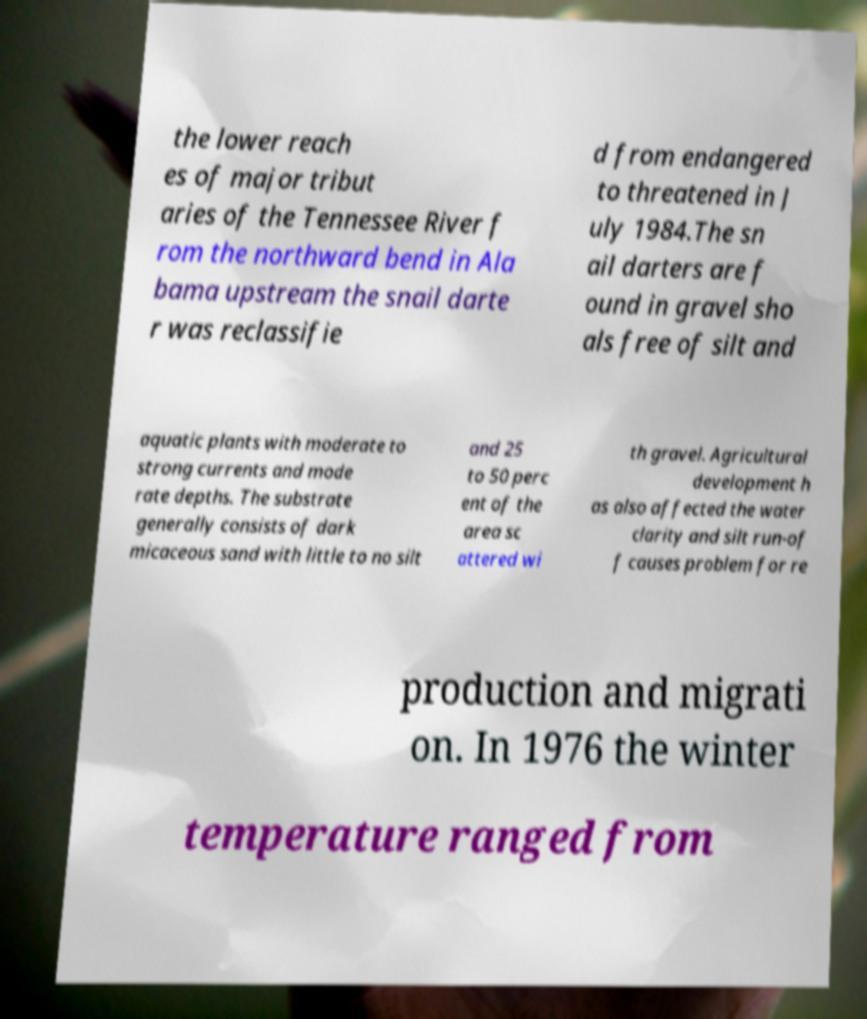There's text embedded in this image that I need extracted. Can you transcribe it verbatim? the lower reach es of major tribut aries of the Tennessee River f rom the northward bend in Ala bama upstream the snail darte r was reclassifie d from endangered to threatened in J uly 1984.The sn ail darters are f ound in gravel sho als free of silt and aquatic plants with moderate to strong currents and mode rate depths. The substrate generally consists of dark micaceous sand with little to no silt and 25 to 50 perc ent of the area sc attered wi th gravel. Agricultural development h as also affected the water clarity and silt run-of f causes problem for re production and migrati on. In 1976 the winter temperature ranged from 